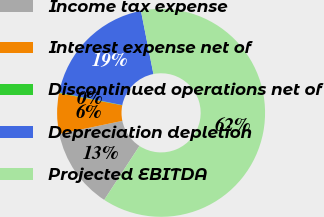Convert chart. <chart><loc_0><loc_0><loc_500><loc_500><pie_chart><fcel>Income tax expense<fcel>Interest expense net of<fcel>Discontinued operations net of<fcel>Depreciation depletion<fcel>Projected EBITDA<nl><fcel>12.53%<fcel>6.31%<fcel>0.09%<fcel>18.76%<fcel>62.32%<nl></chart> 